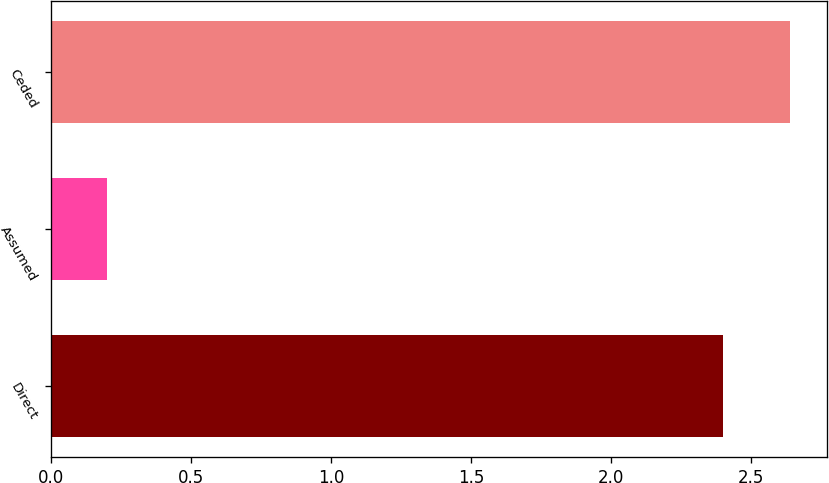<chart> <loc_0><loc_0><loc_500><loc_500><bar_chart><fcel>Direct<fcel>Assumed<fcel>Ceded<nl><fcel>2.4<fcel>0.2<fcel>2.64<nl></chart> 